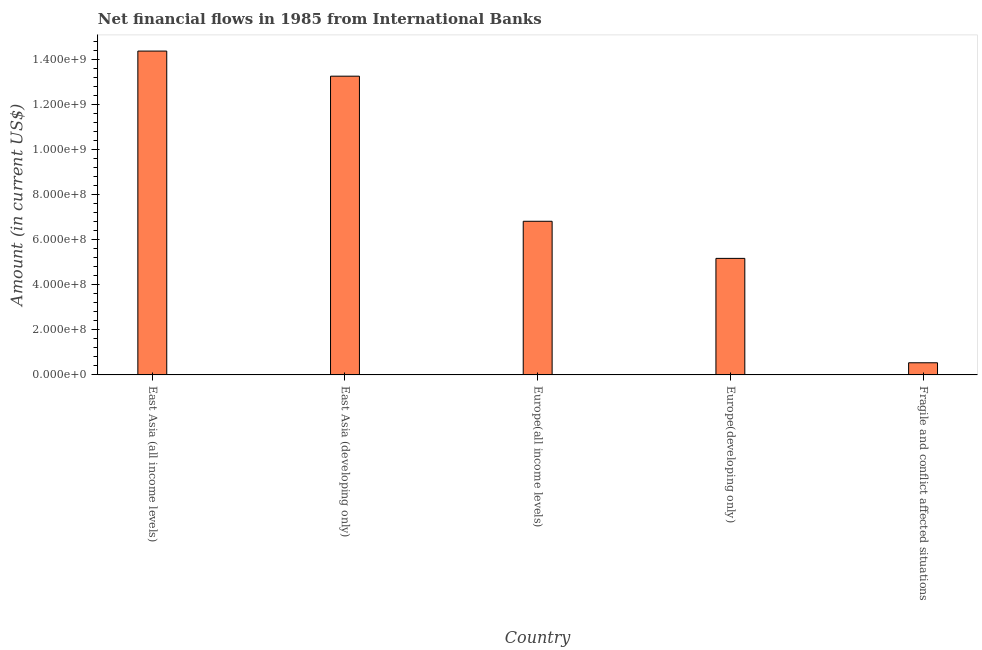Does the graph contain any zero values?
Ensure brevity in your answer.  No. What is the title of the graph?
Offer a very short reply. Net financial flows in 1985 from International Banks. What is the net financial flows from ibrd in Europe(all income levels)?
Ensure brevity in your answer.  6.83e+08. Across all countries, what is the maximum net financial flows from ibrd?
Keep it short and to the point. 1.44e+09. Across all countries, what is the minimum net financial flows from ibrd?
Ensure brevity in your answer.  5.39e+07. In which country was the net financial flows from ibrd maximum?
Keep it short and to the point. East Asia (all income levels). In which country was the net financial flows from ibrd minimum?
Your answer should be very brief. Fragile and conflict affected situations. What is the sum of the net financial flows from ibrd?
Make the answer very short. 4.02e+09. What is the difference between the net financial flows from ibrd in East Asia (all income levels) and Fragile and conflict affected situations?
Offer a very short reply. 1.38e+09. What is the average net financial flows from ibrd per country?
Provide a succinct answer. 8.04e+08. What is the median net financial flows from ibrd?
Your response must be concise. 6.83e+08. What is the ratio of the net financial flows from ibrd in East Asia (all income levels) to that in Fragile and conflict affected situations?
Provide a succinct answer. 26.68. Is the difference between the net financial flows from ibrd in East Asia (developing only) and Europe(developing only) greater than the difference between any two countries?
Your answer should be very brief. No. What is the difference between the highest and the second highest net financial flows from ibrd?
Offer a terse response. 1.12e+08. Is the sum of the net financial flows from ibrd in Europe(all income levels) and Europe(developing only) greater than the maximum net financial flows from ibrd across all countries?
Provide a succinct answer. No. What is the difference between the highest and the lowest net financial flows from ibrd?
Provide a short and direct response. 1.38e+09. How many countries are there in the graph?
Ensure brevity in your answer.  5. What is the Amount (in current US$) of East Asia (all income levels)?
Ensure brevity in your answer.  1.44e+09. What is the Amount (in current US$) in East Asia (developing only)?
Provide a short and direct response. 1.33e+09. What is the Amount (in current US$) of Europe(all income levels)?
Your answer should be very brief. 6.83e+08. What is the Amount (in current US$) in Europe(developing only)?
Provide a short and direct response. 5.18e+08. What is the Amount (in current US$) in Fragile and conflict affected situations?
Your answer should be compact. 5.39e+07. What is the difference between the Amount (in current US$) in East Asia (all income levels) and East Asia (developing only)?
Offer a very short reply. 1.12e+08. What is the difference between the Amount (in current US$) in East Asia (all income levels) and Europe(all income levels)?
Provide a short and direct response. 7.56e+08. What is the difference between the Amount (in current US$) in East Asia (all income levels) and Europe(developing only)?
Your answer should be very brief. 9.21e+08. What is the difference between the Amount (in current US$) in East Asia (all income levels) and Fragile and conflict affected situations?
Provide a succinct answer. 1.38e+09. What is the difference between the Amount (in current US$) in East Asia (developing only) and Europe(all income levels)?
Make the answer very short. 6.45e+08. What is the difference between the Amount (in current US$) in East Asia (developing only) and Europe(developing only)?
Give a very brief answer. 8.09e+08. What is the difference between the Amount (in current US$) in East Asia (developing only) and Fragile and conflict affected situations?
Keep it short and to the point. 1.27e+09. What is the difference between the Amount (in current US$) in Europe(all income levels) and Europe(developing only)?
Offer a terse response. 1.65e+08. What is the difference between the Amount (in current US$) in Europe(all income levels) and Fragile and conflict affected situations?
Make the answer very short. 6.29e+08. What is the difference between the Amount (in current US$) in Europe(developing only) and Fragile and conflict affected situations?
Make the answer very short. 4.64e+08. What is the ratio of the Amount (in current US$) in East Asia (all income levels) to that in East Asia (developing only)?
Provide a succinct answer. 1.08. What is the ratio of the Amount (in current US$) in East Asia (all income levels) to that in Europe(all income levels)?
Ensure brevity in your answer.  2.11. What is the ratio of the Amount (in current US$) in East Asia (all income levels) to that in Europe(developing only)?
Your answer should be very brief. 2.78. What is the ratio of the Amount (in current US$) in East Asia (all income levels) to that in Fragile and conflict affected situations?
Your answer should be compact. 26.68. What is the ratio of the Amount (in current US$) in East Asia (developing only) to that in Europe(all income levels)?
Give a very brief answer. 1.94. What is the ratio of the Amount (in current US$) in East Asia (developing only) to that in Europe(developing only)?
Provide a short and direct response. 2.56. What is the ratio of the Amount (in current US$) in East Asia (developing only) to that in Fragile and conflict affected situations?
Offer a terse response. 24.61. What is the ratio of the Amount (in current US$) in Europe(all income levels) to that in Europe(developing only)?
Keep it short and to the point. 1.32. What is the ratio of the Amount (in current US$) in Europe(all income levels) to that in Fragile and conflict affected situations?
Offer a terse response. 12.66. What is the ratio of the Amount (in current US$) in Europe(developing only) to that in Fragile and conflict affected situations?
Ensure brevity in your answer.  9.6. 